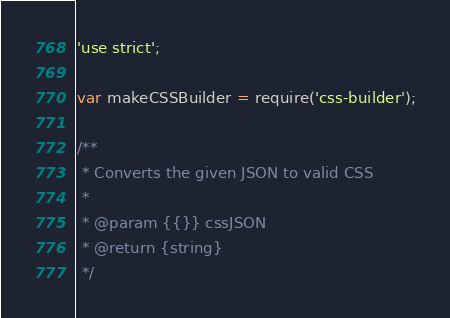<code> <loc_0><loc_0><loc_500><loc_500><_JavaScript_>'use strict';

var makeCSSBuilder = require('css-builder');

/**
 * Converts the given JSON to valid CSS
 *
 * @param {{}} cssJSON
 * @return {string}
 */</code> 